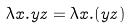Convert formula to latex. <formula><loc_0><loc_0><loc_500><loc_500>\lambda x . y z = \lambda x . ( y z )</formula> 